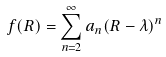Convert formula to latex. <formula><loc_0><loc_0><loc_500><loc_500>f ( R ) = \sum _ { n = 2 } ^ { \infty } a _ { n } ( R - \lambda ) ^ { n }</formula> 